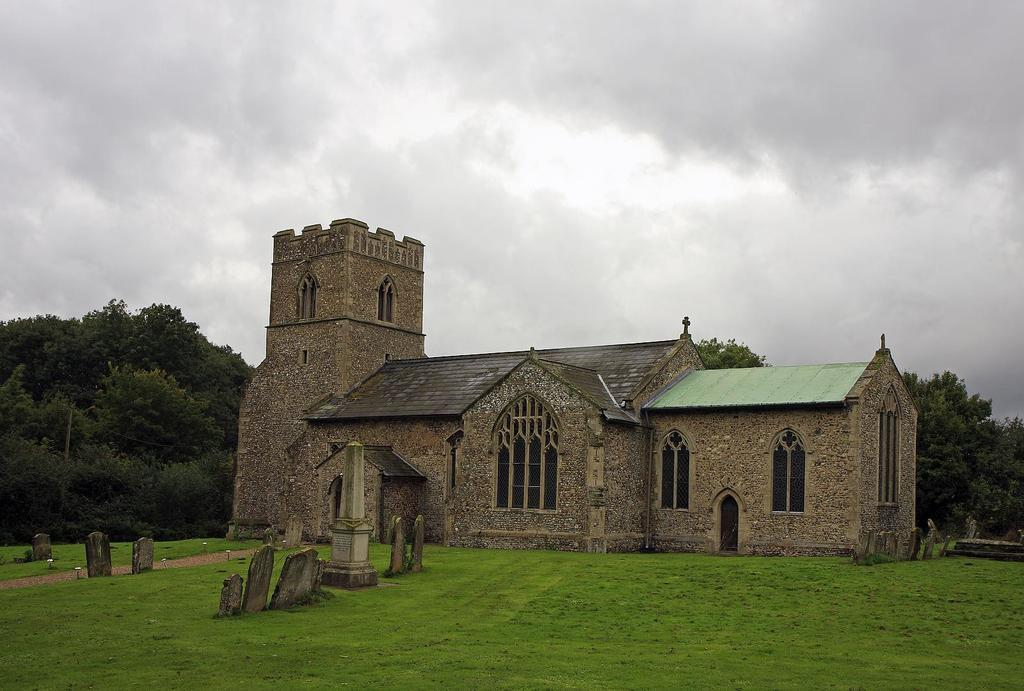What type of vegetation is present on the ground in the image? There is grass on the ground in the image. What can be seen in the background of the image? There is a building, trees, and stones in the background of the image. What is visible in the sky in the image? There are clouds in the sky in the image. How many ladybugs can be seen crawling on the ink in the image? There are no ladybugs or ink present in the image. What type of books can be found in the library depicted in the image? There is no library depicted in the image. 